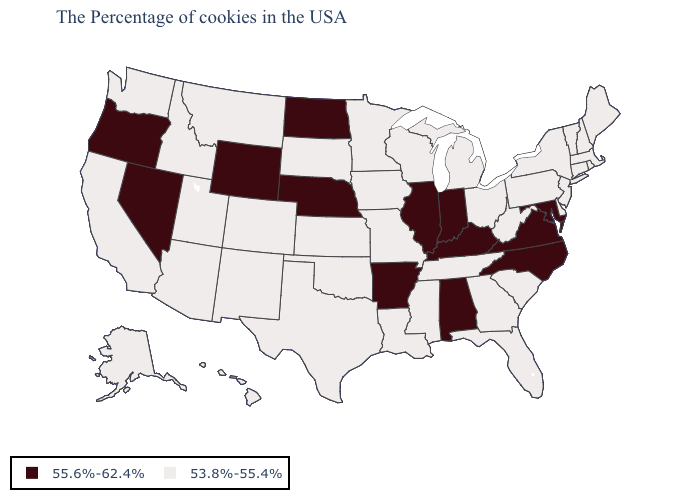Name the states that have a value in the range 55.6%-62.4%?
Answer briefly. Maryland, Virginia, North Carolina, Kentucky, Indiana, Alabama, Illinois, Arkansas, Nebraska, North Dakota, Wyoming, Nevada, Oregon. Name the states that have a value in the range 53.8%-55.4%?
Short answer required. Maine, Massachusetts, Rhode Island, New Hampshire, Vermont, Connecticut, New York, New Jersey, Delaware, Pennsylvania, South Carolina, West Virginia, Ohio, Florida, Georgia, Michigan, Tennessee, Wisconsin, Mississippi, Louisiana, Missouri, Minnesota, Iowa, Kansas, Oklahoma, Texas, South Dakota, Colorado, New Mexico, Utah, Montana, Arizona, Idaho, California, Washington, Alaska, Hawaii. What is the value of Florida?
Short answer required. 53.8%-55.4%. Which states have the highest value in the USA?
Concise answer only. Maryland, Virginia, North Carolina, Kentucky, Indiana, Alabama, Illinois, Arkansas, Nebraska, North Dakota, Wyoming, Nevada, Oregon. Name the states that have a value in the range 53.8%-55.4%?
Write a very short answer. Maine, Massachusetts, Rhode Island, New Hampshire, Vermont, Connecticut, New York, New Jersey, Delaware, Pennsylvania, South Carolina, West Virginia, Ohio, Florida, Georgia, Michigan, Tennessee, Wisconsin, Mississippi, Louisiana, Missouri, Minnesota, Iowa, Kansas, Oklahoma, Texas, South Dakota, Colorado, New Mexico, Utah, Montana, Arizona, Idaho, California, Washington, Alaska, Hawaii. Which states have the lowest value in the South?
Be succinct. Delaware, South Carolina, West Virginia, Florida, Georgia, Tennessee, Mississippi, Louisiana, Oklahoma, Texas. How many symbols are there in the legend?
Keep it brief. 2. What is the lowest value in the USA?
Be succinct. 53.8%-55.4%. Name the states that have a value in the range 53.8%-55.4%?
Write a very short answer. Maine, Massachusetts, Rhode Island, New Hampshire, Vermont, Connecticut, New York, New Jersey, Delaware, Pennsylvania, South Carolina, West Virginia, Ohio, Florida, Georgia, Michigan, Tennessee, Wisconsin, Mississippi, Louisiana, Missouri, Minnesota, Iowa, Kansas, Oklahoma, Texas, South Dakota, Colorado, New Mexico, Utah, Montana, Arizona, Idaho, California, Washington, Alaska, Hawaii. Name the states that have a value in the range 55.6%-62.4%?
Write a very short answer. Maryland, Virginia, North Carolina, Kentucky, Indiana, Alabama, Illinois, Arkansas, Nebraska, North Dakota, Wyoming, Nevada, Oregon. Name the states that have a value in the range 55.6%-62.4%?
Give a very brief answer. Maryland, Virginia, North Carolina, Kentucky, Indiana, Alabama, Illinois, Arkansas, Nebraska, North Dakota, Wyoming, Nevada, Oregon. Is the legend a continuous bar?
Short answer required. No. What is the value of Washington?
Be succinct. 53.8%-55.4%. Name the states that have a value in the range 55.6%-62.4%?
Short answer required. Maryland, Virginia, North Carolina, Kentucky, Indiana, Alabama, Illinois, Arkansas, Nebraska, North Dakota, Wyoming, Nevada, Oregon. What is the highest value in states that border Rhode Island?
Write a very short answer. 53.8%-55.4%. 